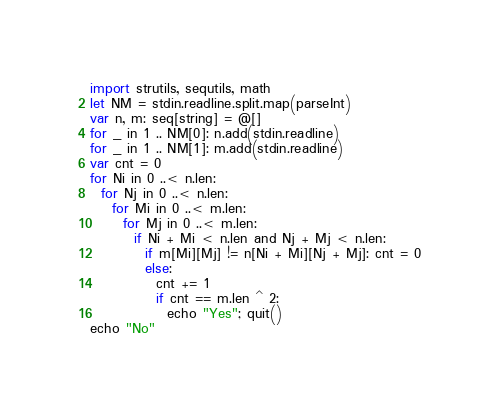<code> <loc_0><loc_0><loc_500><loc_500><_Nim_>import strutils, sequtils, math
let NM = stdin.readline.split.map(parseInt)
var n, m: seq[string] = @[]
for _ in 1 .. NM[0]: n.add(stdin.readline)
for _ in 1 .. NM[1]: m.add(stdin.readline)
var cnt = 0
for Ni in 0 ..< n.len:
  for Nj in 0 ..< n.len:
    for Mi in 0 ..< m.len:
      for Mj in 0 ..< m.len:
        if Ni + Mi < n.len and Nj + Mj < n.len:
          if m[Mi][Mj] != n[Ni + Mi][Nj + Mj]: cnt = 0
          else:
            cnt += 1
            if cnt == m.len ^ 2:
              echo "Yes"; quit()
echo "No"
</code> 